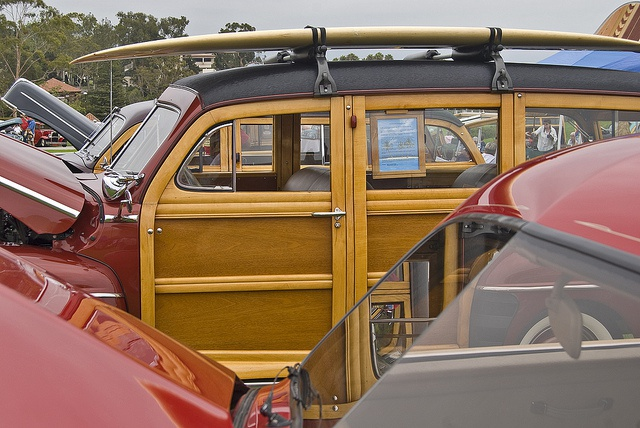Describe the objects in this image and their specific colors. I can see car in darkgreen, olive, gray, tan, and maroon tones, car in darkgreen, gray, darkgray, and lightpink tones, car in darkgreen, salmon, and brown tones, surfboard in darkgreen, black, olive, gray, and tan tones, and car in darkgreen, lightgray, darkgray, gray, and black tones in this image. 